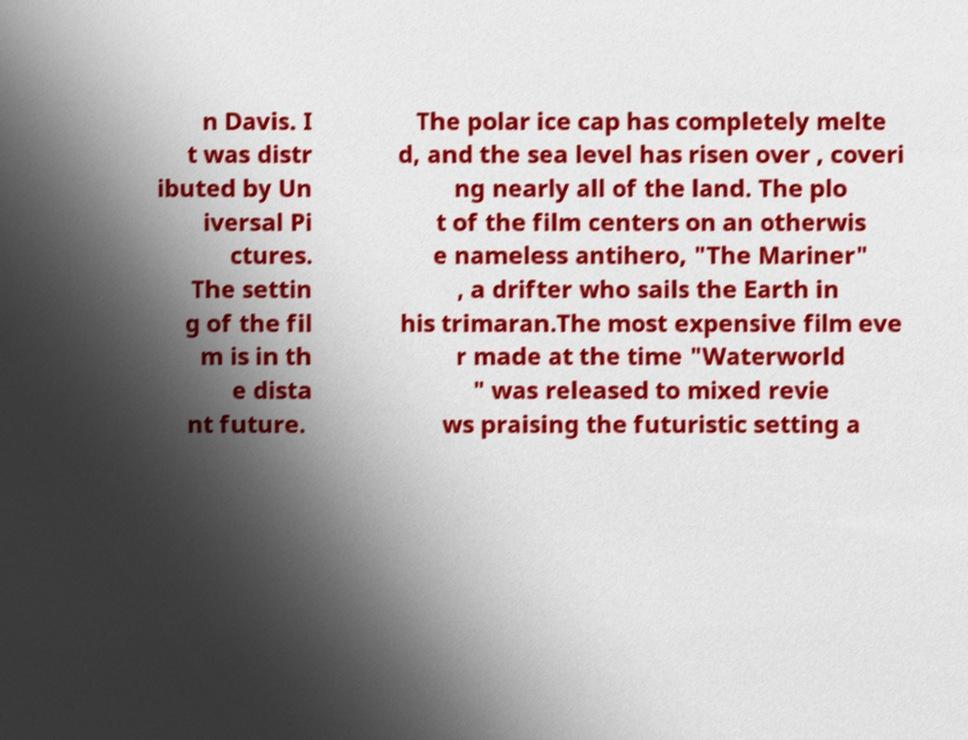Can you read and provide the text displayed in the image?This photo seems to have some interesting text. Can you extract and type it out for me? n Davis. I t was distr ibuted by Un iversal Pi ctures. The settin g of the fil m is in th e dista nt future. The polar ice cap has completely melte d, and the sea level has risen over , coveri ng nearly all of the land. The plo t of the film centers on an otherwis e nameless antihero, "The Mariner" , a drifter who sails the Earth in his trimaran.The most expensive film eve r made at the time "Waterworld " was released to mixed revie ws praising the futuristic setting a 